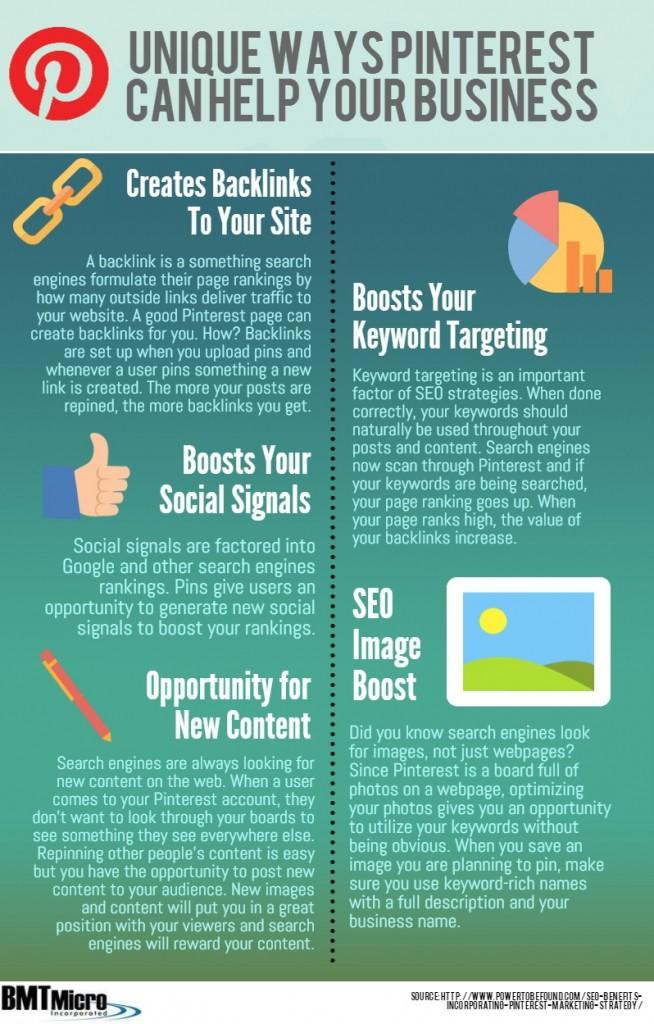Give some essential details in this illustration. Pinterest can assist businesses in various ways, with a total of 5 ways identified. 